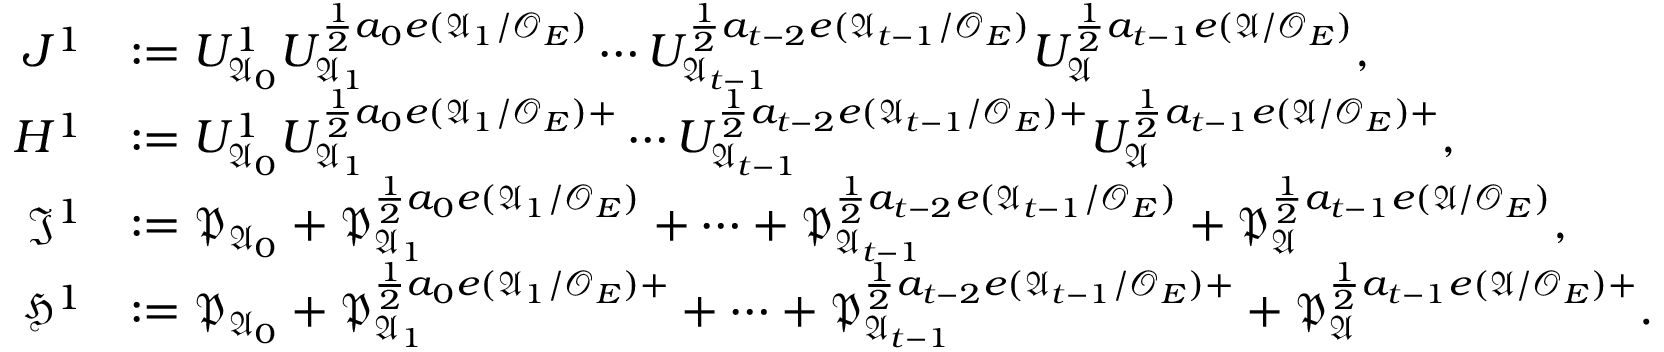<formula> <loc_0><loc_0><loc_500><loc_500>\begin{array} { r l } { J ^ { 1 } } & { \colon = U _ { \mathfrak { A } _ { 0 } } ^ { 1 } U _ { \mathfrak { A } _ { 1 } } ^ { \frac { 1 } { 2 } a _ { 0 } e ( \mathfrak { A } _ { 1 } / \mathcal { O } _ { E } ) } \cdots U _ { \mathfrak { A } _ { t - 1 } } ^ { \frac { 1 } { 2 } a _ { t - 2 } e ( \mathfrak { A } _ { t - 1 } / \mathcal { O } _ { E } ) } U _ { \mathfrak { A } } ^ { \frac { 1 } { 2 } a _ { t - 1 } e ( \mathfrak { A } / \mathcal { O } _ { E } ) } , } \\ { H ^ { 1 } } & { \colon = U _ { \mathfrak { A } _ { 0 } } ^ { 1 } U _ { \mathfrak { A } _ { 1 } } ^ { \frac { 1 } { 2 } a _ { 0 } e ( \mathfrak { A } _ { 1 } / \mathcal { O } _ { E } ) + } \cdots U _ { \mathfrak { A } _ { t - 1 } } ^ { \frac { 1 } { 2 } a _ { t - 2 } e ( \mathfrak { A } _ { t - 1 } / \mathcal { O } _ { E } ) + } U _ { \mathfrak { A } } ^ { \frac { 1 } { 2 } a _ { t - 1 } e ( \mathfrak { A } / \mathcal { O } _ { E } ) + } , } \\ { \mathfrak { J } ^ { 1 } } & { \colon = \mathfrak { P } _ { \mathfrak { A } _ { 0 } } + \mathfrak { P } _ { \mathfrak { A } _ { 1 } } ^ { \frac { 1 } { 2 } a _ { 0 } e ( \mathfrak { A } _ { 1 } / \mathcal { O } _ { E } ) } + \cdots + \mathfrak { P } _ { \mathfrak { A } _ { t - 1 } } ^ { \frac { 1 } { 2 } a _ { t - 2 } e ( \mathfrak { A } _ { t - 1 } / \mathcal { O } _ { E } ) } + \mathfrak { P } _ { \mathfrak { A } } ^ { \frac { 1 } { 2 } a _ { t - 1 } e ( \mathfrak { A } / \mathcal { O } _ { E } ) } , } \\ { \mathfrak { H } ^ { 1 } } & { \colon = \mathfrak { P } _ { \mathfrak { A } _ { 0 } } + \mathfrak { P } _ { \mathfrak { A } _ { 1 } } ^ { \frac { 1 } { 2 } a _ { 0 } e ( \mathfrak { A } _ { 1 } / \mathcal { O } _ { E } ) + } + \cdots + \mathfrak { P } _ { \mathfrak { A } _ { t - 1 } } ^ { \frac { 1 } { 2 } a _ { t - 2 } e ( \mathfrak { A } _ { t - 1 } / \mathcal { O } _ { E } ) + } + \mathfrak { P } _ { \mathfrak { A } } ^ { \frac { 1 } { 2 } a _ { t - 1 } e ( \mathfrak { A } / \mathcal { O } _ { E } ) + } . } \end{array}</formula> 